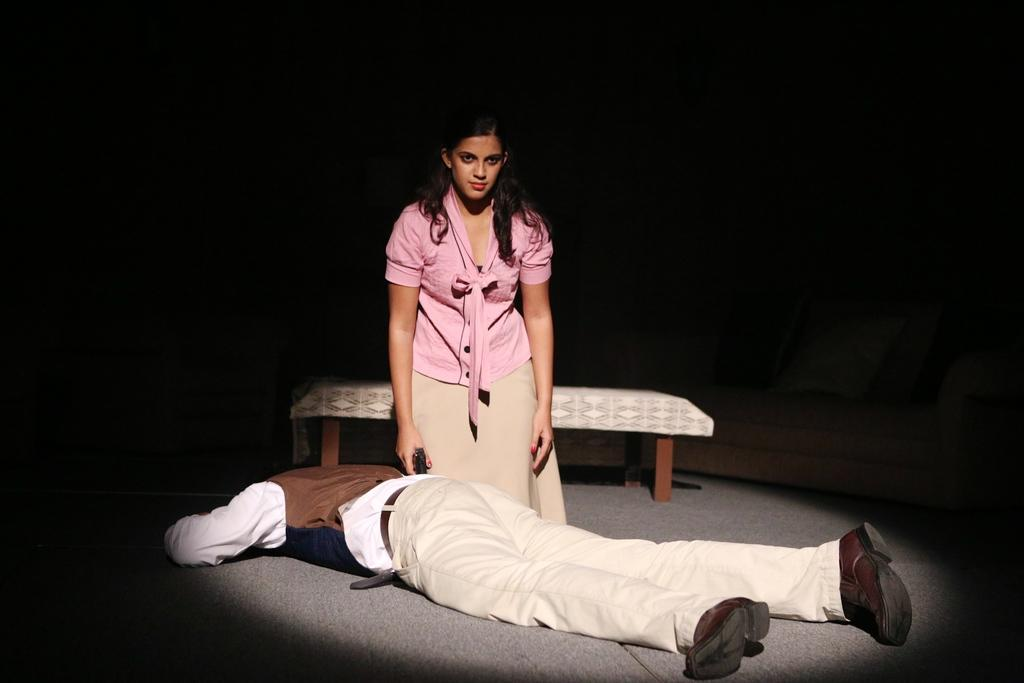What is the position of the person in the image? There is a person lying on the floor in the image. Can you describe the other person in the image? There is a girl standing in the image. What can be seen in the background of the image? There is a bed visible in the background of the image. What type of watch is the person wearing in the image? There is no watch visible in the image. What is the person using the wrench for in the image? There is no wrench present in the image. 